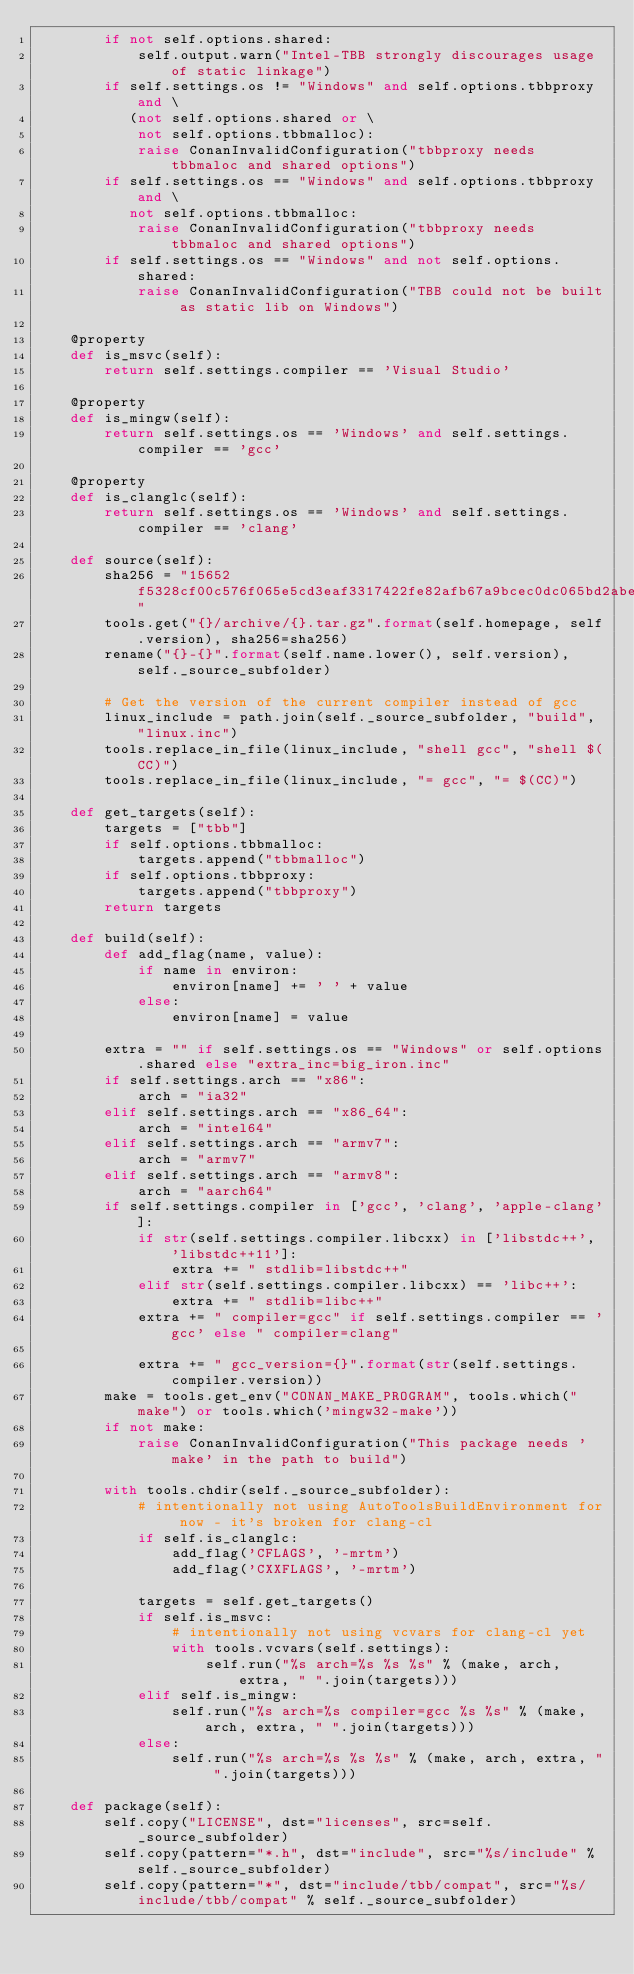Convert code to text. <code><loc_0><loc_0><loc_500><loc_500><_Python_>        if not self.options.shared:
            self.output.warn("Intel-TBB strongly discourages usage of static linkage")
        if self.settings.os != "Windows" and self.options.tbbproxy and \
           (not self.options.shared or \
            not self.options.tbbmalloc):
            raise ConanInvalidConfiguration("tbbproxy needs tbbmaloc and shared options")
        if self.settings.os == "Windows" and self.options.tbbproxy and \
           not self.options.tbbmalloc:
            raise ConanInvalidConfiguration("tbbproxy needs tbbmaloc and shared options")
        if self.settings.os == "Windows" and not self.options.shared:
            raise ConanInvalidConfiguration("TBB could not be built as static lib on Windows")

    @property
    def is_msvc(self):
        return self.settings.compiler == 'Visual Studio'

    @property
    def is_mingw(self):
        return self.settings.os == 'Windows' and self.settings.compiler == 'gcc'

    @property
    def is_clanglc(self):
        return self.settings.os == 'Windows' and self.settings.compiler == 'clang'

    def source(self):
        sha256 = "15652f5328cf00c576f065e5cd3eaf3317422fe82afb67a9bcec0dc065bd2abe"
        tools.get("{}/archive/{}.tar.gz".format(self.homepage, self.version), sha256=sha256)
        rename("{}-{}".format(self.name.lower(), self.version), self._source_subfolder)

        # Get the version of the current compiler instead of gcc
        linux_include = path.join(self._source_subfolder, "build", "linux.inc")
        tools.replace_in_file(linux_include, "shell gcc", "shell $(CC)")
        tools.replace_in_file(linux_include, "= gcc", "= $(CC)")

    def get_targets(self):
        targets = ["tbb"]
        if self.options.tbbmalloc:
            targets.append("tbbmalloc")
        if self.options.tbbproxy:
            targets.append("tbbproxy")
        return targets

    def build(self):
        def add_flag(name, value):
            if name in environ:
                environ[name] += ' ' + value
            else:
                environ[name] = value

        extra = "" if self.settings.os == "Windows" or self.options.shared else "extra_inc=big_iron.inc"
        if self.settings.arch == "x86":
            arch = "ia32"
        elif self.settings.arch == "x86_64":
            arch = "intel64"
        elif self.settings.arch == "armv7":
            arch = "armv7"
        elif self.settings.arch == "armv8":
            arch = "aarch64"
        if self.settings.compiler in ['gcc', 'clang', 'apple-clang']:
            if str(self.settings.compiler.libcxx) in ['libstdc++', 'libstdc++11']:
                extra += " stdlib=libstdc++"
            elif str(self.settings.compiler.libcxx) == 'libc++':
                extra += " stdlib=libc++"
            extra += " compiler=gcc" if self.settings.compiler == 'gcc' else " compiler=clang"

            extra += " gcc_version={}".format(str(self.settings.compiler.version))
        make = tools.get_env("CONAN_MAKE_PROGRAM", tools.which("make") or tools.which('mingw32-make'))
        if not make:
            raise ConanInvalidConfiguration("This package needs 'make' in the path to build")

        with tools.chdir(self._source_subfolder):
            # intentionally not using AutoToolsBuildEnvironment for now - it's broken for clang-cl
            if self.is_clanglc:
                add_flag('CFLAGS', '-mrtm')
                add_flag('CXXFLAGS', '-mrtm')

            targets = self.get_targets()
            if self.is_msvc:
                # intentionally not using vcvars for clang-cl yet
                with tools.vcvars(self.settings):
                    self.run("%s arch=%s %s %s" % (make, arch, extra, " ".join(targets)))
            elif self.is_mingw:
                self.run("%s arch=%s compiler=gcc %s %s" % (make, arch, extra, " ".join(targets)))
            else:
                self.run("%s arch=%s %s %s" % (make, arch, extra, " ".join(targets)))

    def package(self):
        self.copy("LICENSE", dst="licenses", src=self._source_subfolder)
        self.copy(pattern="*.h", dst="include", src="%s/include" % self._source_subfolder)
        self.copy(pattern="*", dst="include/tbb/compat", src="%s/include/tbb/compat" % self._source_subfolder)</code> 